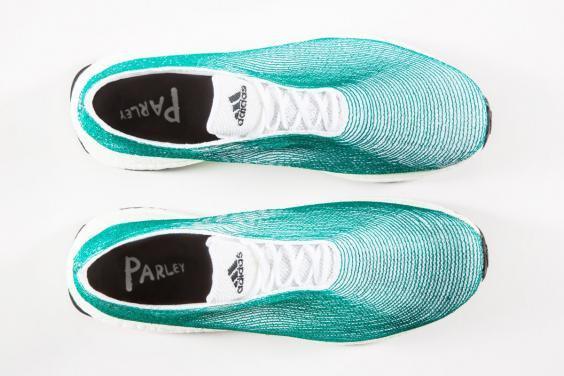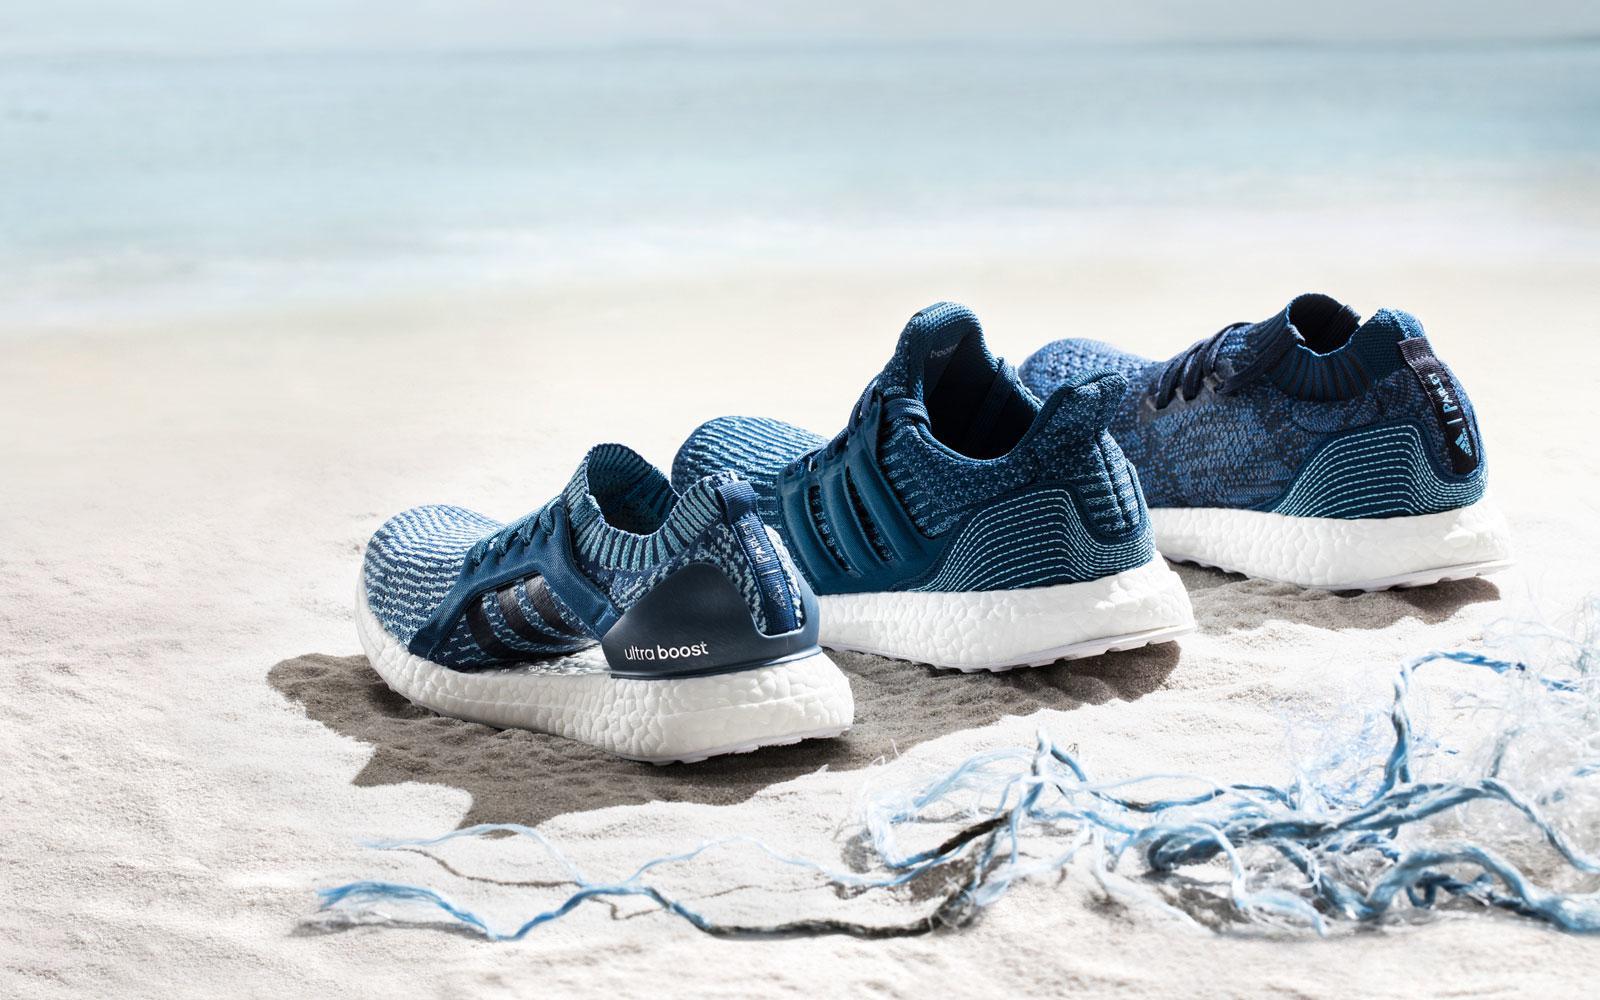The first image is the image on the left, the second image is the image on the right. For the images displayed, is the sentence "An image shows blue sneakers posed with a tangle of fibrous strings." factually correct? Answer yes or no. Yes. The first image is the image on the left, the second image is the image on the right. Assess this claim about the two images: "There are more than three shoes.". Correct or not? Answer yes or no. Yes. 